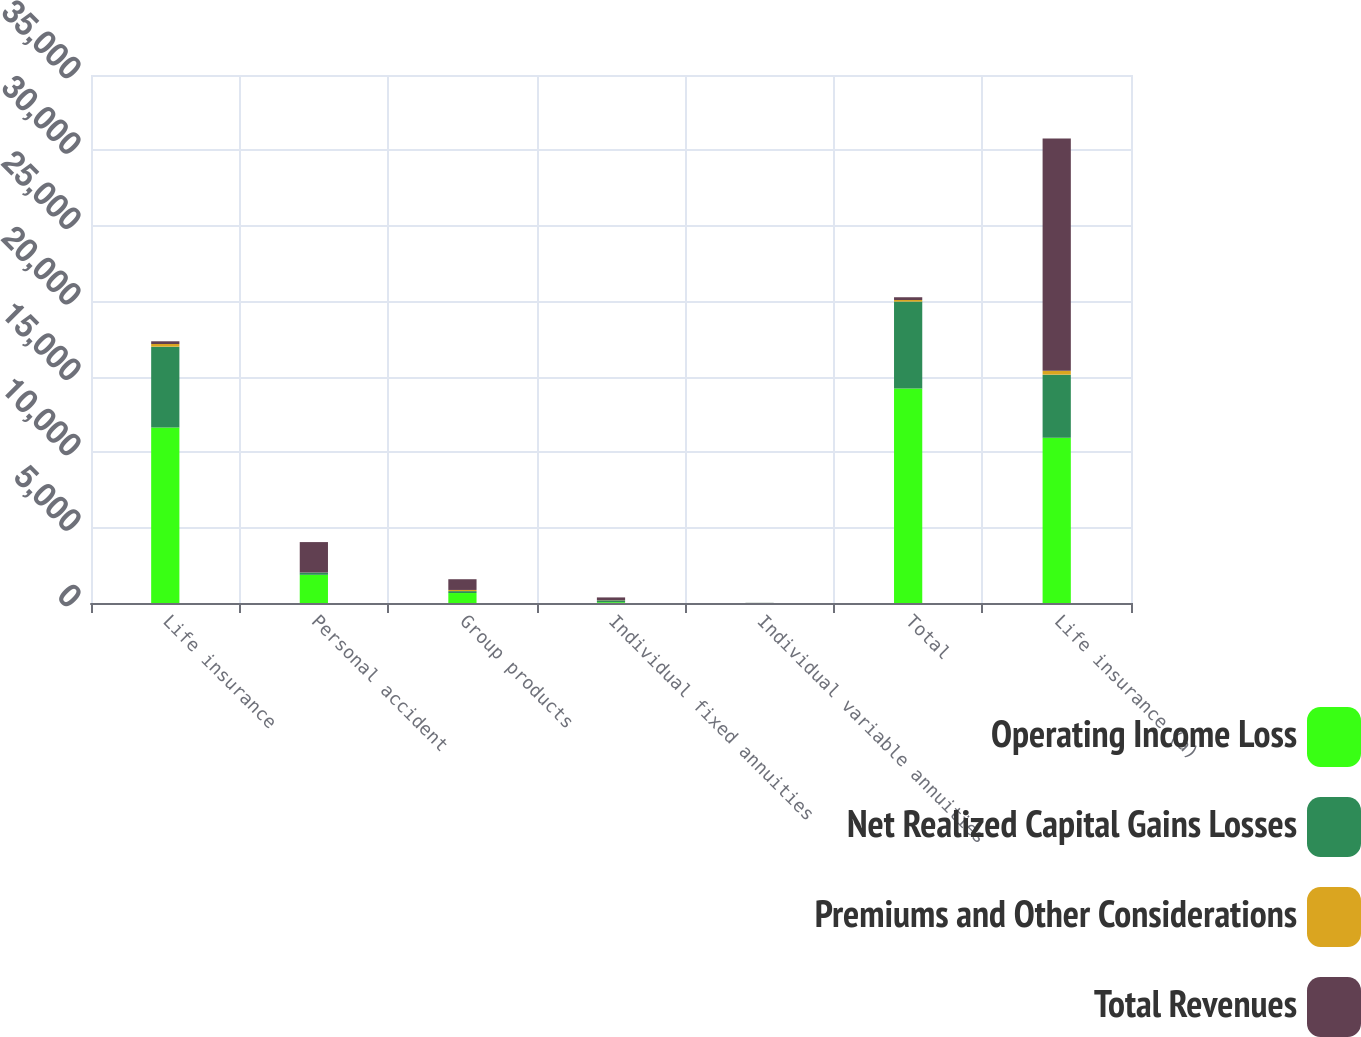Convert chart. <chart><loc_0><loc_0><loc_500><loc_500><stacked_bar_chart><ecel><fcel>Life insurance<fcel>Personal accident<fcel>Group products<fcel>Individual fixed annuities<fcel>Individual variable annuities<fcel>Total<fcel>Life insurance (a)<nl><fcel>Operating Income Loss<fcel>11631<fcel>1869<fcel>661<fcel>52<fcel>1<fcel>14214<fcel>10949<nl><fcel>Net Realized Capital Gains Losses<fcel>5360<fcel>150<fcel>127<fcel>123<fcel>6<fcel>5766<fcel>4188<nl><fcel>Premiums and Other Considerations<fcel>177<fcel>2<fcel>77<fcel>10<fcel>1<fcel>107<fcel>258<nl><fcel>Total Revenues<fcel>181<fcel>2017<fcel>711<fcel>185<fcel>6<fcel>181<fcel>15395<nl></chart> 